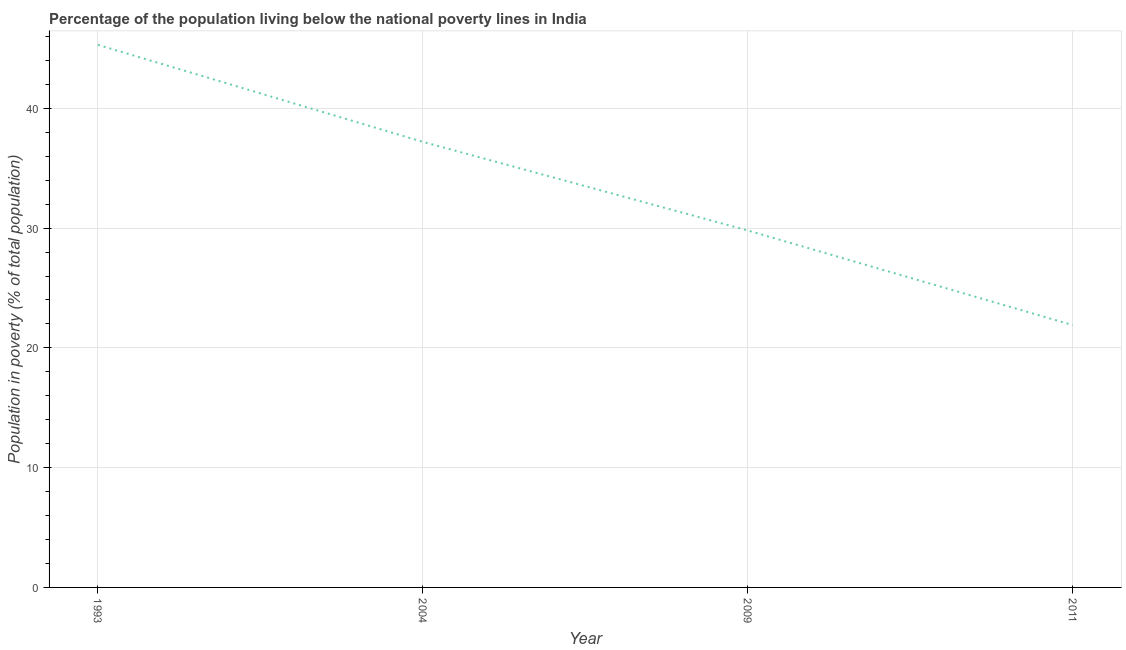What is the percentage of population living below poverty line in 2011?
Your response must be concise. 21.9. Across all years, what is the maximum percentage of population living below poverty line?
Provide a succinct answer. 45.3. Across all years, what is the minimum percentage of population living below poverty line?
Your answer should be very brief. 21.9. What is the sum of the percentage of population living below poverty line?
Your answer should be very brief. 134.2. What is the difference between the percentage of population living below poverty line in 1993 and 2004?
Your answer should be very brief. 8.1. What is the average percentage of population living below poverty line per year?
Ensure brevity in your answer.  33.55. What is the median percentage of population living below poverty line?
Offer a terse response. 33.5. In how many years, is the percentage of population living below poverty line greater than 22 %?
Provide a short and direct response. 3. Do a majority of the years between 2004 and 1993 (inclusive) have percentage of population living below poverty line greater than 16 %?
Provide a succinct answer. No. What is the ratio of the percentage of population living below poverty line in 1993 to that in 2011?
Provide a short and direct response. 2.07. Is the difference between the percentage of population living below poverty line in 1993 and 2011 greater than the difference between any two years?
Provide a short and direct response. Yes. What is the difference between the highest and the second highest percentage of population living below poverty line?
Ensure brevity in your answer.  8.1. What is the difference between the highest and the lowest percentage of population living below poverty line?
Ensure brevity in your answer.  23.4. In how many years, is the percentage of population living below poverty line greater than the average percentage of population living below poverty line taken over all years?
Provide a succinct answer. 2. Does the percentage of population living below poverty line monotonically increase over the years?
Give a very brief answer. No. Are the values on the major ticks of Y-axis written in scientific E-notation?
Your response must be concise. No. Does the graph contain any zero values?
Offer a very short reply. No. What is the title of the graph?
Your answer should be very brief. Percentage of the population living below the national poverty lines in India. What is the label or title of the Y-axis?
Your answer should be very brief. Population in poverty (% of total population). What is the Population in poverty (% of total population) of 1993?
Your answer should be very brief. 45.3. What is the Population in poverty (% of total population) of 2004?
Give a very brief answer. 37.2. What is the Population in poverty (% of total population) in 2009?
Ensure brevity in your answer.  29.8. What is the Population in poverty (% of total population) in 2011?
Offer a terse response. 21.9. What is the difference between the Population in poverty (% of total population) in 1993 and 2011?
Your answer should be very brief. 23.4. What is the difference between the Population in poverty (% of total population) in 2004 and 2011?
Provide a succinct answer. 15.3. What is the ratio of the Population in poverty (% of total population) in 1993 to that in 2004?
Your response must be concise. 1.22. What is the ratio of the Population in poverty (% of total population) in 1993 to that in 2009?
Keep it short and to the point. 1.52. What is the ratio of the Population in poverty (% of total population) in 1993 to that in 2011?
Provide a short and direct response. 2.07. What is the ratio of the Population in poverty (% of total population) in 2004 to that in 2009?
Make the answer very short. 1.25. What is the ratio of the Population in poverty (% of total population) in 2004 to that in 2011?
Give a very brief answer. 1.7. What is the ratio of the Population in poverty (% of total population) in 2009 to that in 2011?
Ensure brevity in your answer.  1.36. 